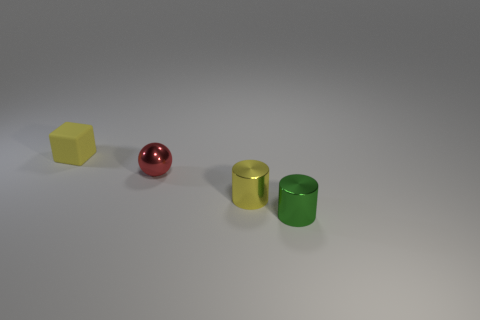What material do the objects in the image seem to be made of? The objects appear to be made of a smooth, rigid material, possibly plastic or a polished, matte-finish metal, giving them a simplistic and clean aesthetic. 